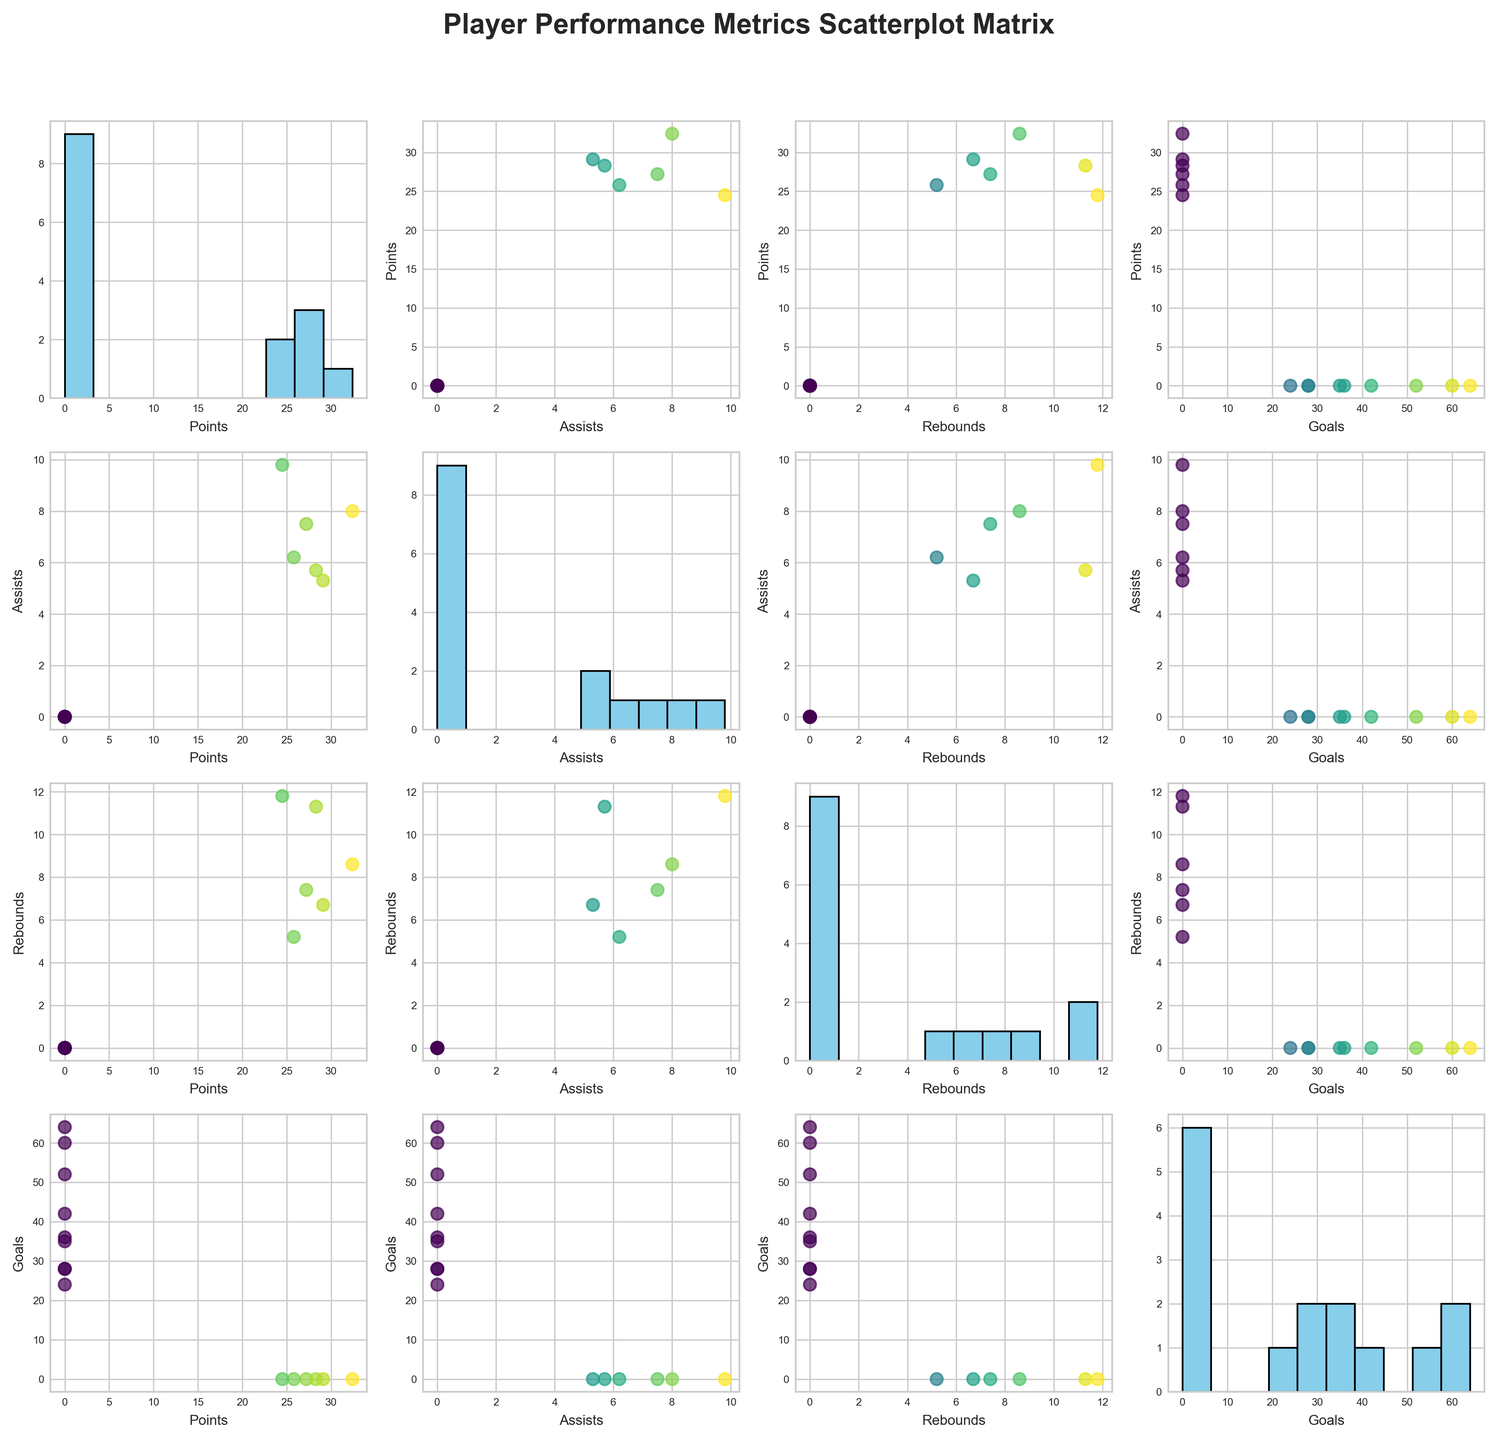What is the title of the figure? The title of the figure is located at the top and serves as a general description of what the scatterplot matrix represents.
Answer: "Player Performance Metrics Scatterplot Matrix" How many different metrics are represented in the scatterplot matrix? Each row and column represents a different metric. By counting the unique labels on the axes, we see there are four metrics.
Answer: 4 Which metric appears on both axes of a subplot that shows a histogram instead of a scatter plot? In the scatterplot matrix, diagonal subplots show histograms. Each histogram subplot represents a metric with itself on both the x and y axes.
Answer: The same metric appears on both axes How many bins are used in the histograms within the diagonal subplots? By closely observing the histograms, you can count the number of bars (bins) present.
Answer: 10 Looking at the scatter plot between Points and Assists, does any player stand out with noticeably high values in both categories? Examine the scatter plot where 'Points' is on one axis and 'Assists' on the other. Identify if there is an outlier with high values in both metrics.
Answer: Luka Doncic Which distribution among Points, Assists, and Rebounds appears most spread out based on the histograms? By comparing the width and spread of the bars in each histogram in the diagonal subplots, you can determine which histogram covers a larger range.
Answer: Rebounds Is there any correlation between Goals and Points? Look at the scatter plot where 'Goals' is on one axis and 'Points' on the other, and evaluate the pattern of the points.
Answer: No clear correlation Who might be the outlier in the scatter plot between Goals and Rebounds, based on their performance? Refer to the scatter plot where 'Goals' and 'Rebounds' are plotted against each other and identify a point that deviates significantly from the cluster.
Answer: Nikola Jokic Comparing Assists and Rebounds, which metric seems to have a higher average based on the scatter plot? By observing the scatter plot where 'Assists' and 'Rebounds' are plotted, you can judge which metric generally has higher values.
Answer: Rebounds In the matrix, which scatter plot appears densest with data points? Evaluate all scatter plots to determine which one has the most closely packed points, indicating a higher density.
Answer: Points vs Assists 